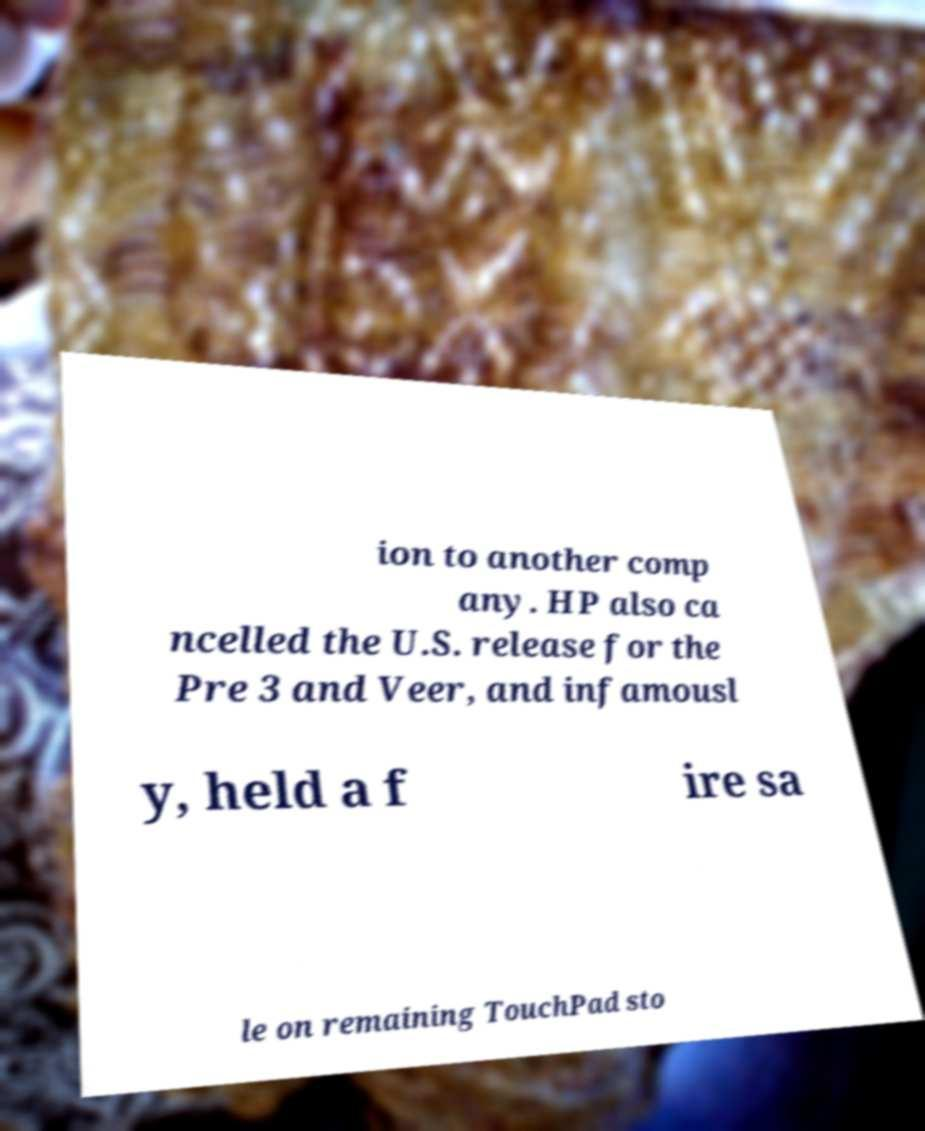Please read and relay the text visible in this image. What does it say? ion to another comp any. HP also ca ncelled the U.S. release for the Pre 3 and Veer, and infamousl y, held a f ire sa le on remaining TouchPad sto 